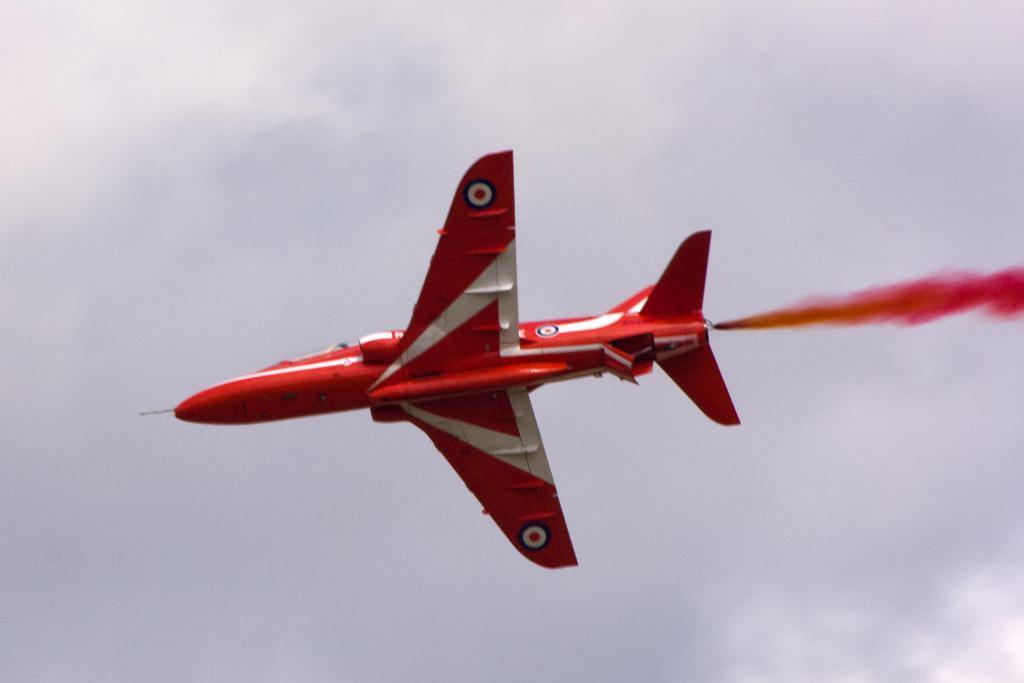Can you describe this image briefly? In this image we can see an airplane is flying and in the background, we can see the sky. 